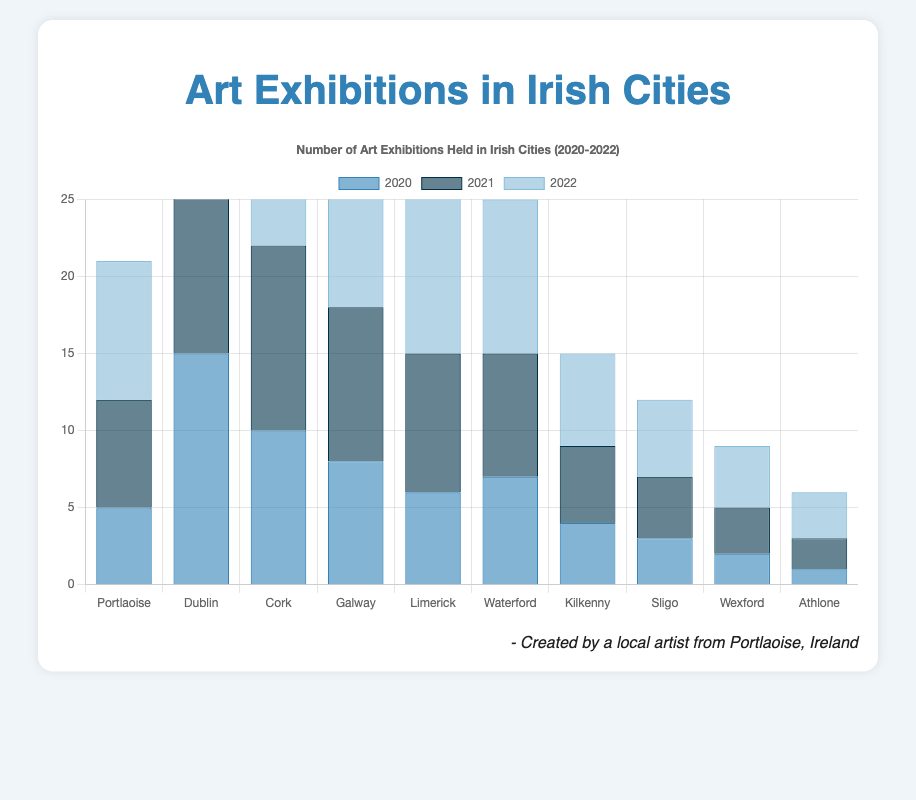Which city had the highest number of art exhibitions in 2022? The figure shows that Dublin had the highest number of art exhibitions in 2022 with a tally of 20.
Answer: Dublin How many more exhibitions were held in Cork in 2022 compared to 2020? In 2022, Cork held 14 exhibitions, while in 2020 it held 10. Subtracting 10 from 14 gives us the difference.
Answer: 4 What was the total number of art exhibitions held in Portlaoise over the three years (2020-2022)? Summing the exhibition numbers for Portlaoise across 2020 (5), 2021 (7), and 2022 (9), we get 5 + 7 + 9 = 21.
Answer: 21 Which year had the lowest number of art exhibitions in Galway? The figure shows that Galway had 8 exhibitions in 2020, 10 exhibitions in 2021, and 11 exhibitions in 2022. 2020 had the lowest number.
Answer: 2020 Compare the increase in the number of art exhibitions from 2020 to 2022 in Limerick and Waterford. Which city had the greater increase? Limerick had 6 exhibitions in 2020 and 13 in 2022, an increase of 7 (13 - 6). Waterford had 7 exhibitions in 2020 and 10 in 2022, an increase of 3 (10 - 7). Limerick had the greater increase.
Answer: Limerick How many cities had fewer than 5 exhibitions in 2021? The cities with fewer than 5 exhibitions in 2021 were Wexford (3), Athlone (2), and Sligo (4). This totals to three cities.
Answer: 3 Which city saw the smallest increase in the number of art exhibitions from 2021 to 2022? The increases from 2021 to 2022 are determined for each city:
Portlaoise: 2 (9 - 7)
Dublin: 2 (20 - 18)
Cork: 2 (14 - 12)
Galway: 1 (11 - 10)
Limerick: 4 (13 - 9)
Waterford: 2 (10 - 8)
Kilkenny: 1 (6 - 5)
Sligo: 1 (5 - 4)
Wexford: 1 (4 - 3)
Athlone: 1 (3 - 2)
All had at least one increase, with Galway, Kilkenny, Sligo, Wexford, and Athlone sharing the smallest increase of 1. However, Galway had the smallest number among these cities in total from 2021 to 2022.
Answer: Galway What was the average number of art exhibitions held in all cities in 2021? Sum all the exhibitions in 2021 (7+18+12+10+9+8+5+4+3+2=78) and divide by the number of cities (10). The average is 78/10 = 7.8.
Answer: 7.8 